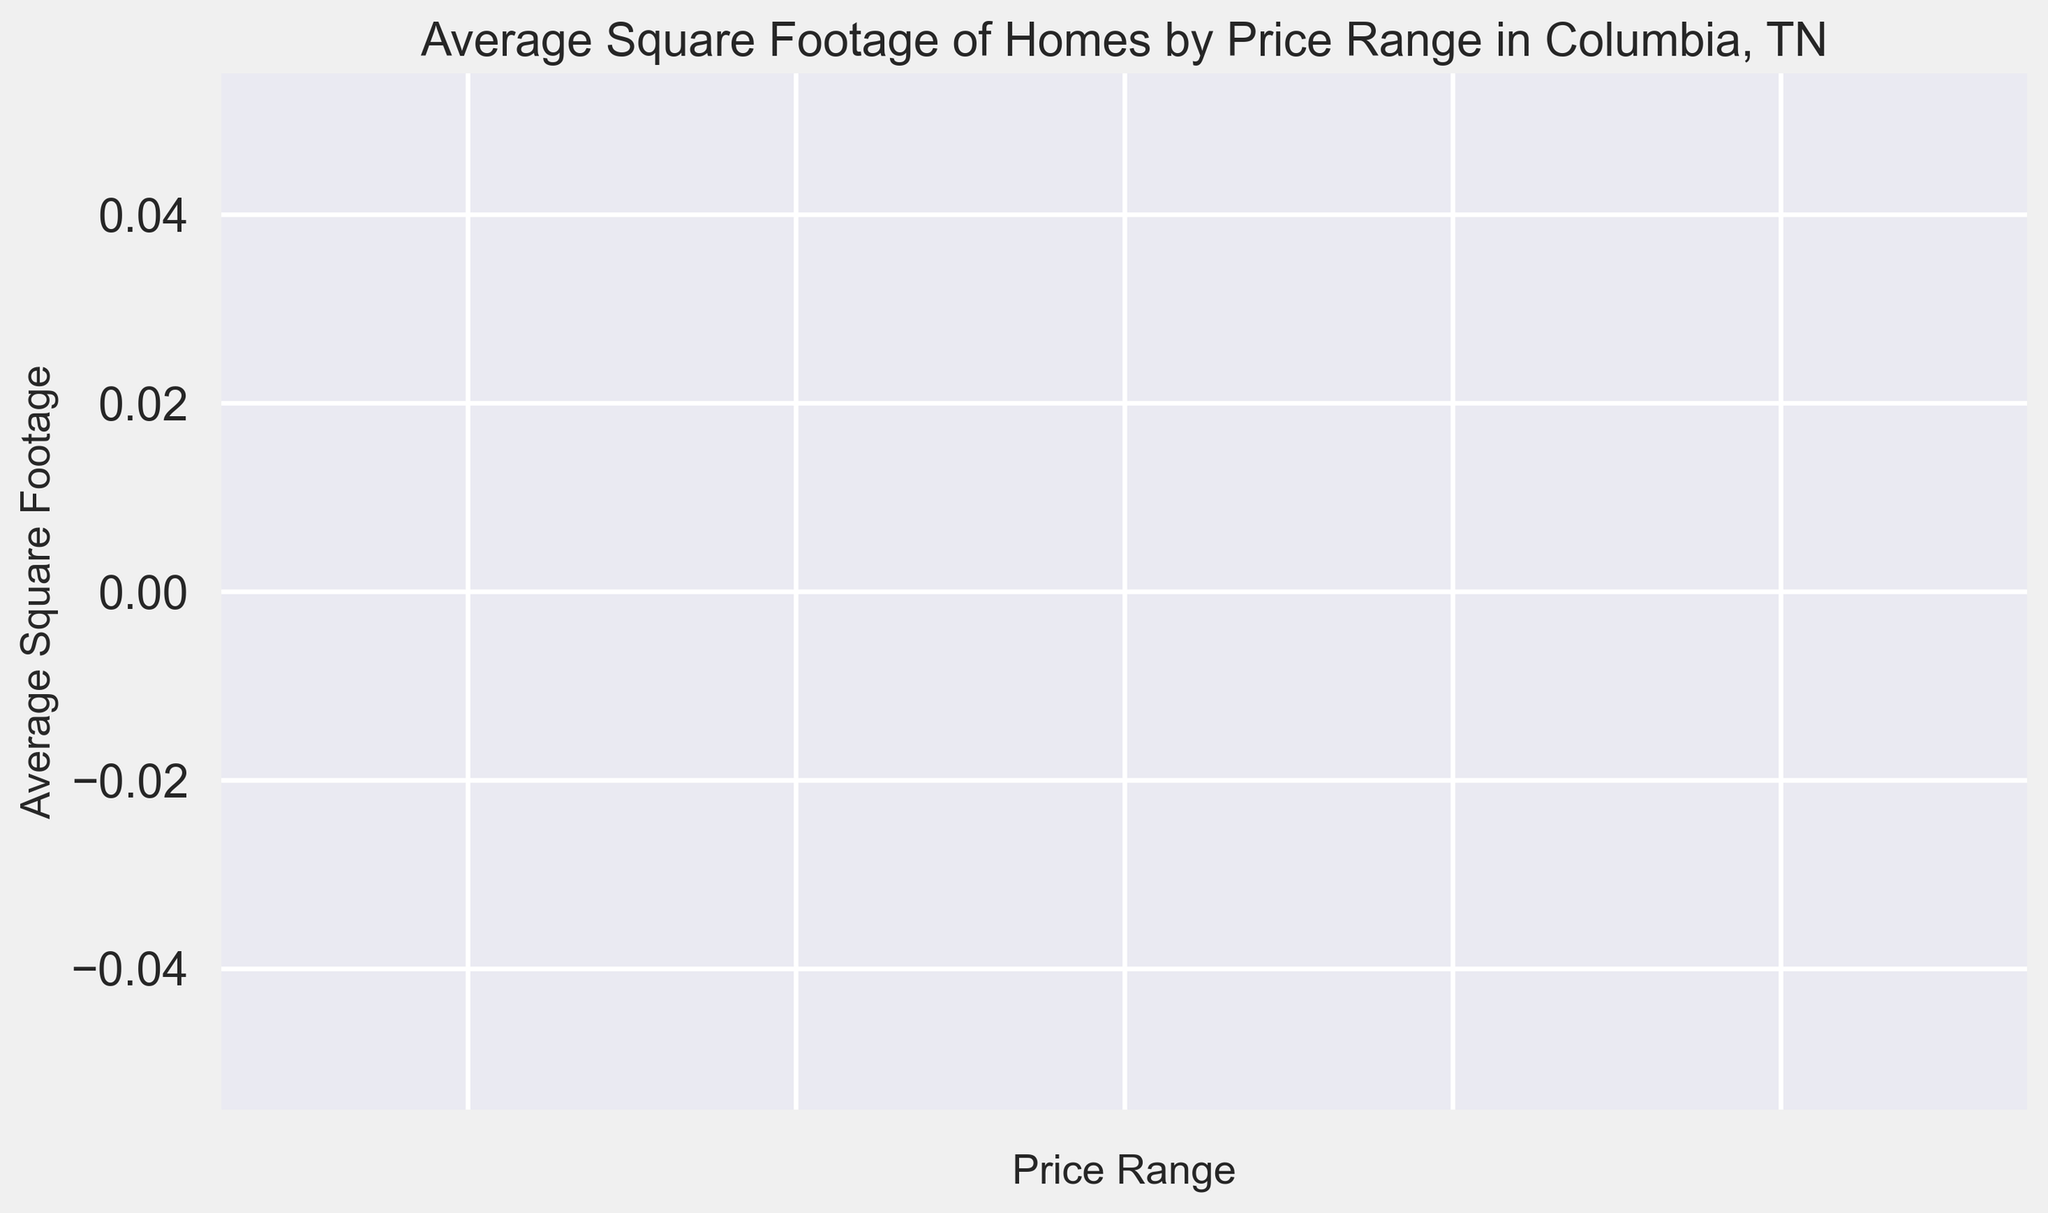What is the highest average square footage among the price ranges? Identify the bar that reaches the highest point on the y-axis. This corresponds to the highest average square footage.
Answer: {highest_value} Which price range has the lowest average square footage? Look for the bar that is the shortest in height, as it represents the lowest value on the y-axis.
Answer: {lowest_value} How does the average square footage for the most expensive price range compare to the least expensive one? Identify the bars belonging to the highest and lowest price ranges, and compare their heights. The taller bar represents greater average square footage.
Answer: {comparison_result} What is the average square footage of homes in the mid-range price category (often the third or fourth bar)? Locate the bars towards the middle of the x-axis range and check their corresponding heights, which indicate the average square footage.
Answer: {mid_range_value} By how much does the average square footage of the highest range exceed the mid-range? Subtract the average square footage of the mid-range price category from that of the highest price category to find the difference.
Answer: {difference_value} Which two price ranges have the most similar average square footage? Compare the heights of all the bars and find the ones that are closest in value.
Answer: {similar_ranges} Describe the trend in average square footage as the price range increases. Observe the pattern of bar heights from left to right. Note whether the bars generally increase, decrease, or show no clear trend.
Answer: {trend_description} What is the combined average square footage of the two most expensive price ranges? Identify the heights of the bars for the two highest price ranges and add them together.
Answer: {combined_value} Is there a price range whose average square footage is exactly the median value of all the ranges? Arrange the bar heights in ascending order and find the middle value. Check if any price range’s bar height matches this median value.
Answer: {median_check} Which price range has nearly half the average square footage of the most expensive price range? Divide the height of the bar for the most expensive range by two. Look for a bar whose height is close to this halved value.
Answer: {half_value_range} 